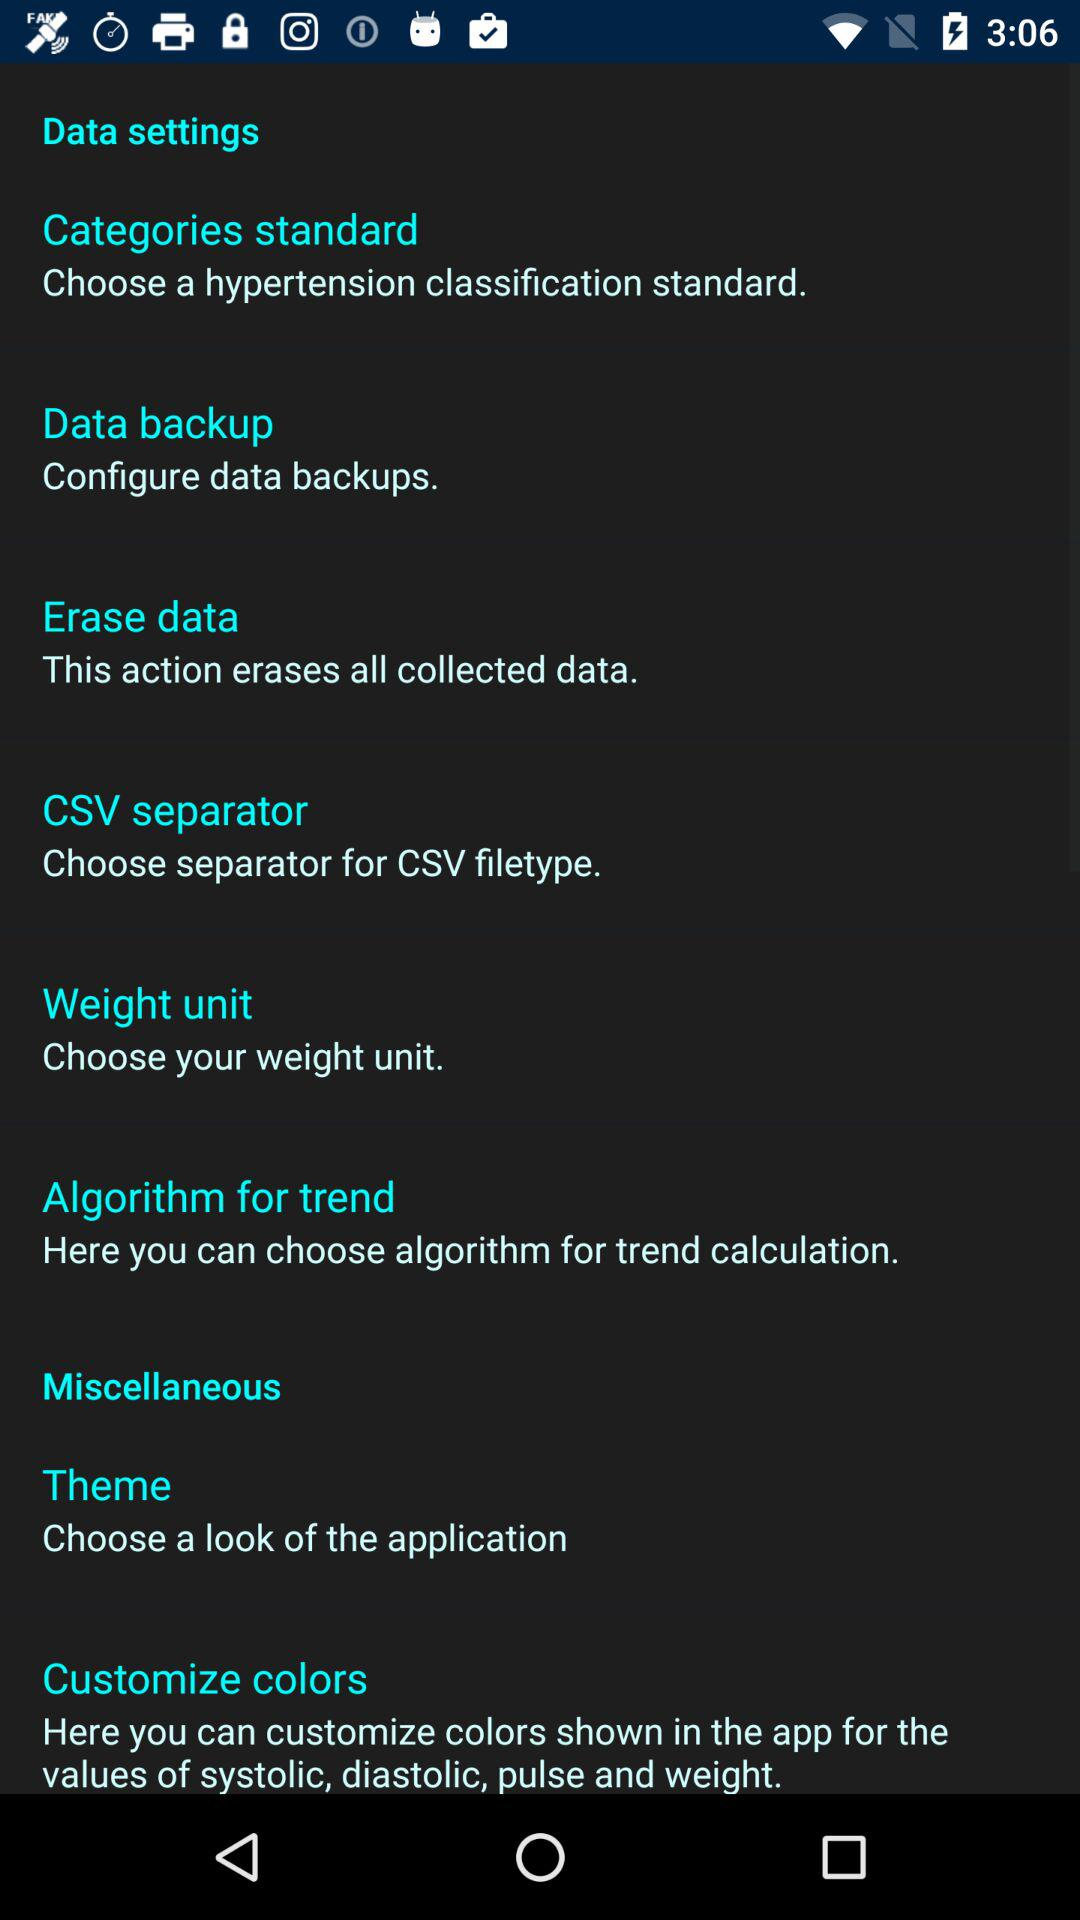What is the work of the CSV separator? The work of the CSV separator is to choose a separator for the CSV filetype. 